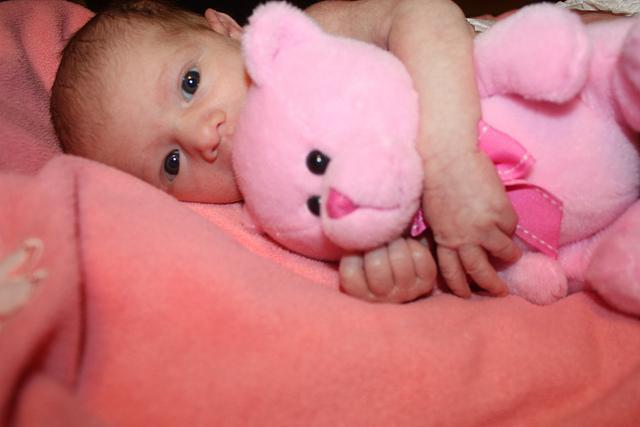How many eyes in the photo?
Give a very brief answer. 4. How many people are there?
Give a very brief answer. 1. How many beds are there?
Give a very brief answer. 1. 